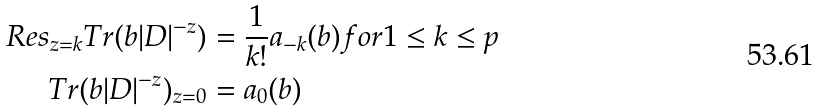Convert formula to latex. <formula><loc_0><loc_0><loc_500><loc_500>R e s _ { z = k } T r ( b | D | ^ { - z } ) & = \frac { 1 } { k ! } a _ { - k } ( b ) f o r 1 \leq k \leq p \\ T r ( b | D | ^ { - z } ) _ { z = 0 } & = a _ { 0 } ( b )</formula> 